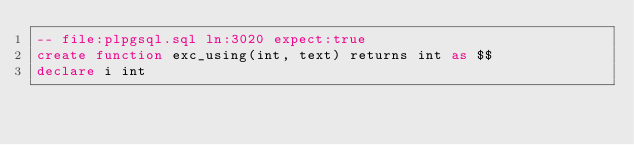Convert code to text. <code><loc_0><loc_0><loc_500><loc_500><_SQL_>-- file:plpgsql.sql ln:3020 expect:true
create function exc_using(int, text) returns int as $$
declare i int
</code> 